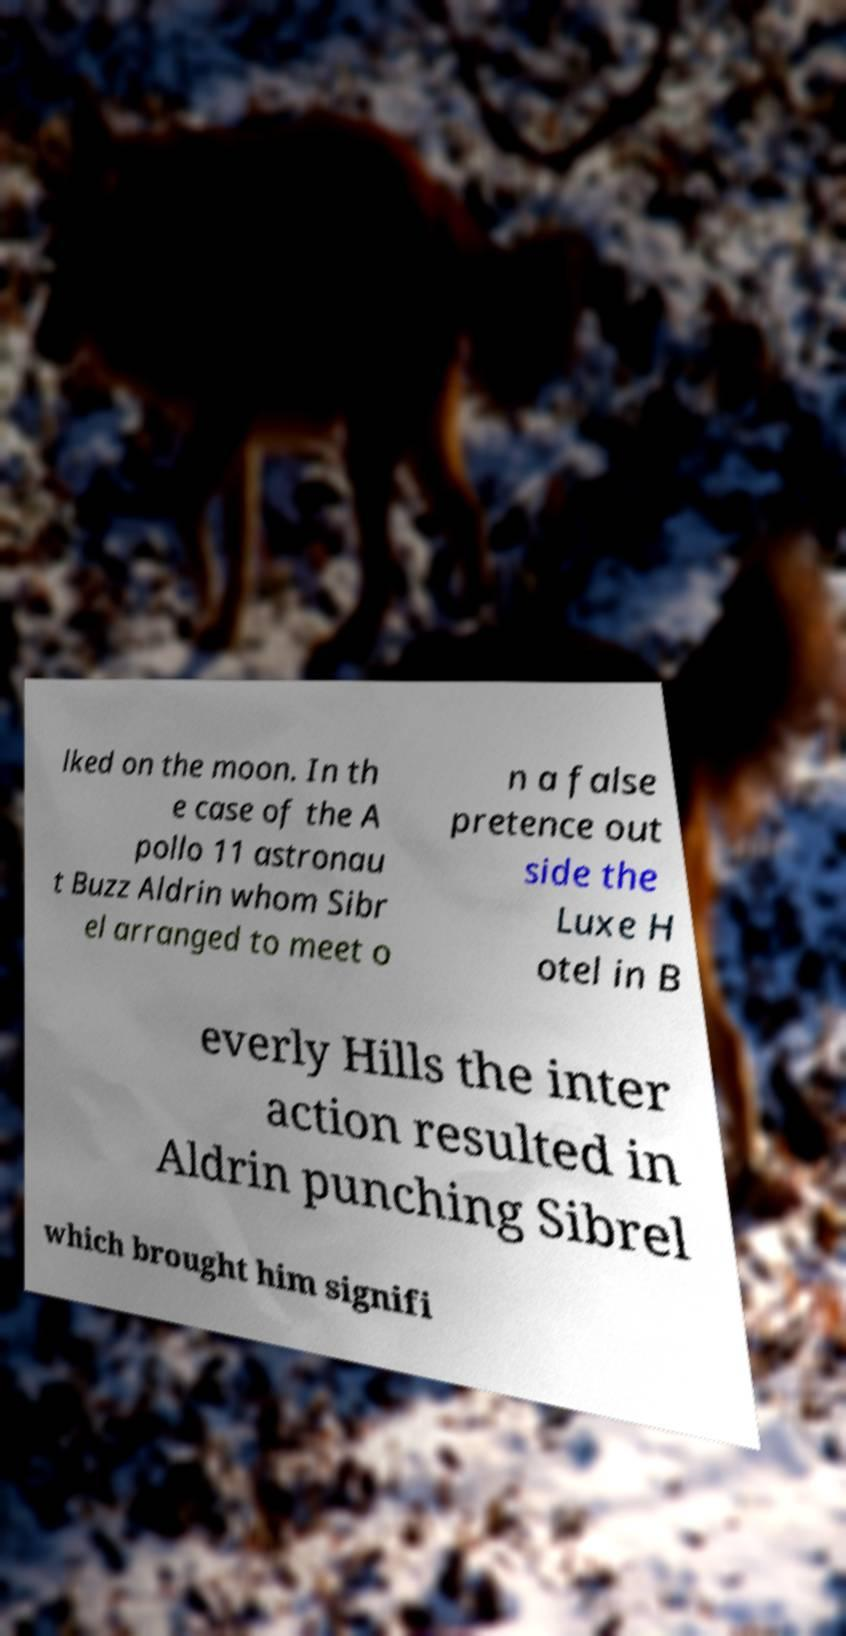Please read and relay the text visible in this image. What does it say? lked on the moon. In th e case of the A pollo 11 astronau t Buzz Aldrin whom Sibr el arranged to meet o n a false pretence out side the Luxe H otel in B everly Hills the inter action resulted in Aldrin punching Sibrel which brought him signifi 